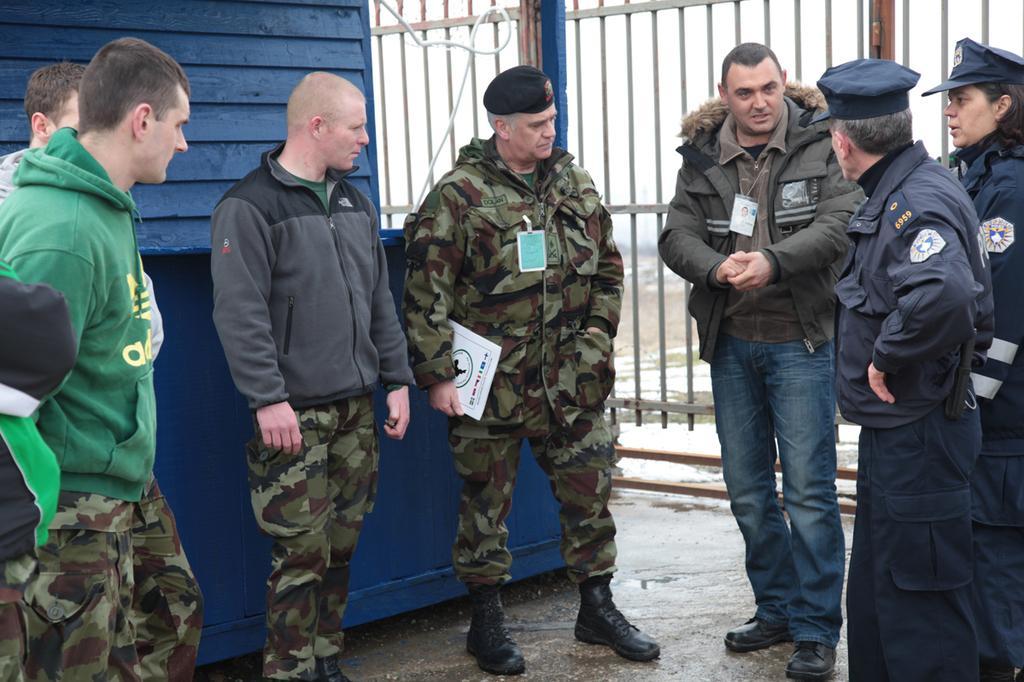Please provide a concise description of this image. In this picture I can see group of people standing, there is a person holding a book, and in the background there are iron grilles and a wall. 